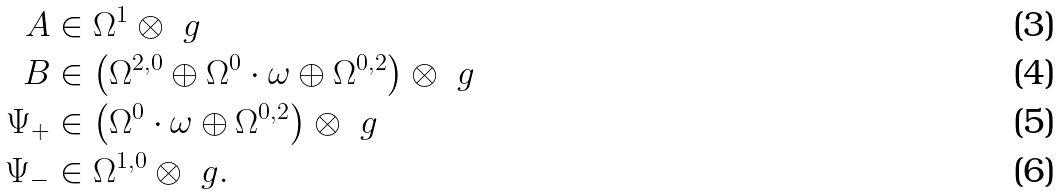<formula> <loc_0><loc_0><loc_500><loc_500>A & \in \Omega ^ { 1 } \otimes \ g \\ B & \in \left ( \Omega ^ { 2 , 0 } \oplus \Omega ^ { 0 } \cdot \omega \oplus \Omega ^ { 0 , 2 } \right ) \otimes \ g \\ \Psi _ { + } & \in \left ( \Omega ^ { 0 } \cdot \omega \oplus \Omega ^ { 0 , 2 } \right ) \otimes \ g \\ \Psi _ { - } & \in \Omega ^ { 1 , 0 } \otimes \ g .</formula> 